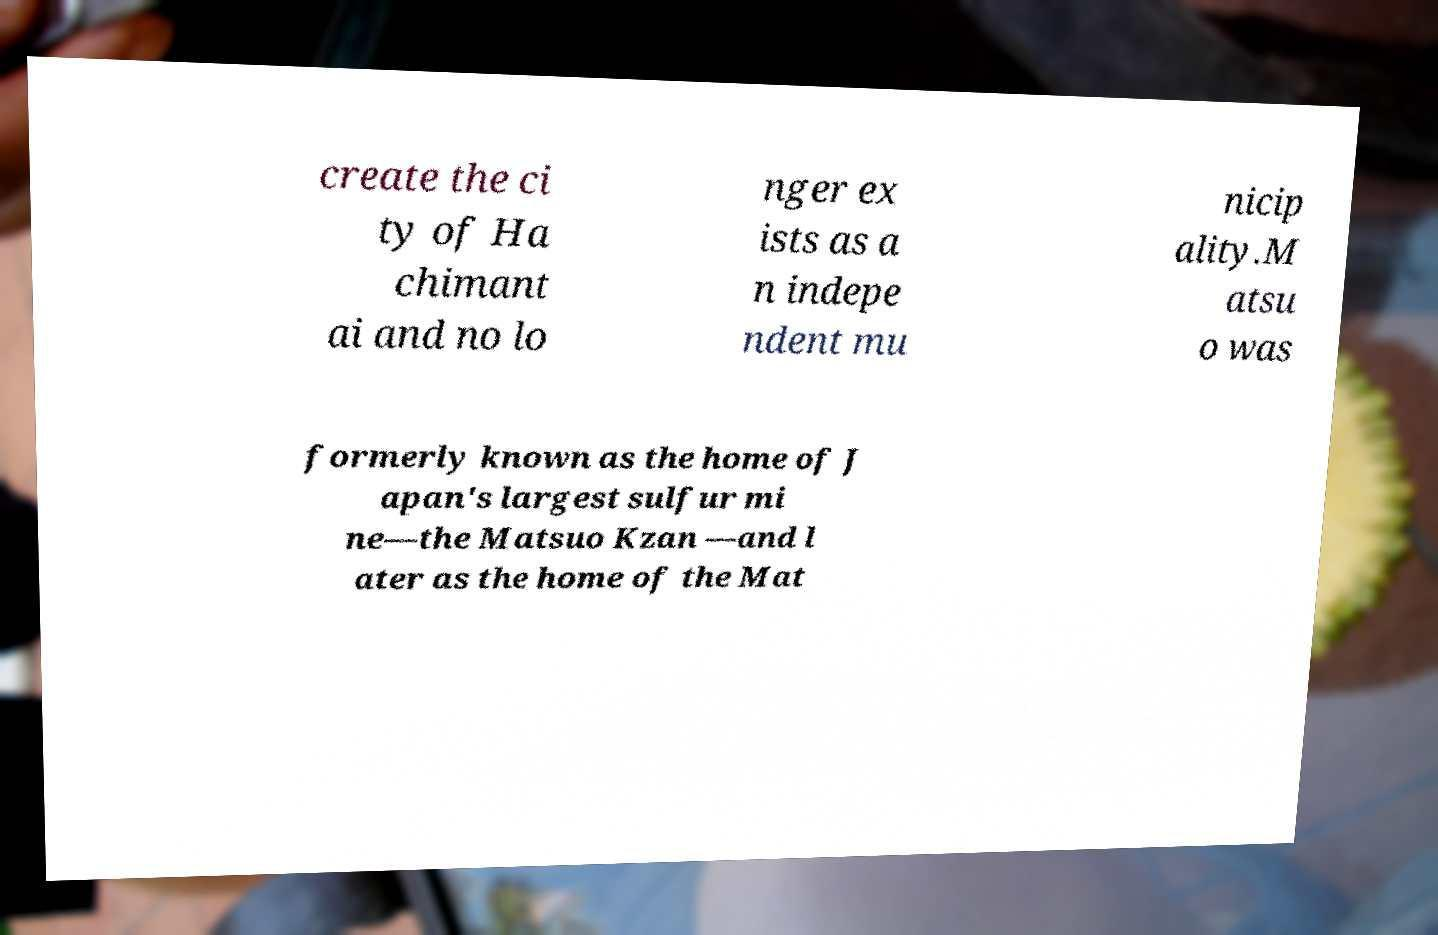What messages or text are displayed in this image? I need them in a readable, typed format. create the ci ty of Ha chimant ai and no lo nger ex ists as a n indepe ndent mu nicip ality.M atsu o was formerly known as the home of J apan's largest sulfur mi ne—the Matsuo Kzan —and l ater as the home of the Mat 